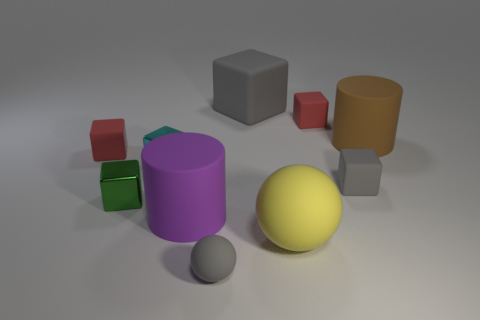Is the number of gray cubes to the left of the small gray rubber block greater than the number of yellow things behind the yellow matte thing?
Give a very brief answer. Yes. How many other things are the same size as the brown matte cylinder?
Provide a succinct answer. 3. Is the color of the tiny sphere that is left of the yellow ball the same as the big cube?
Provide a short and direct response. Yes. Is the number of balls in front of the large purple rubber cylinder greater than the number of tiny gray balls?
Provide a short and direct response. Yes. Is there anything else that has the same color as the tiny sphere?
Give a very brief answer. Yes. What is the shape of the small gray rubber object that is behind the gray matte thing in front of the small gray block?
Keep it short and to the point. Cube. Are there more tiny matte cubes than large matte things?
Give a very brief answer. No. What number of rubber objects are both in front of the small cyan shiny object and behind the purple matte cylinder?
Make the answer very short. 1. There is a large cylinder that is to the right of the large gray matte object; what number of tiny gray rubber blocks are to the left of it?
Your response must be concise. 1. How many objects are red matte cubes on the left side of the large gray rubber thing or small rubber cubes to the right of the large purple object?
Make the answer very short. 3. 